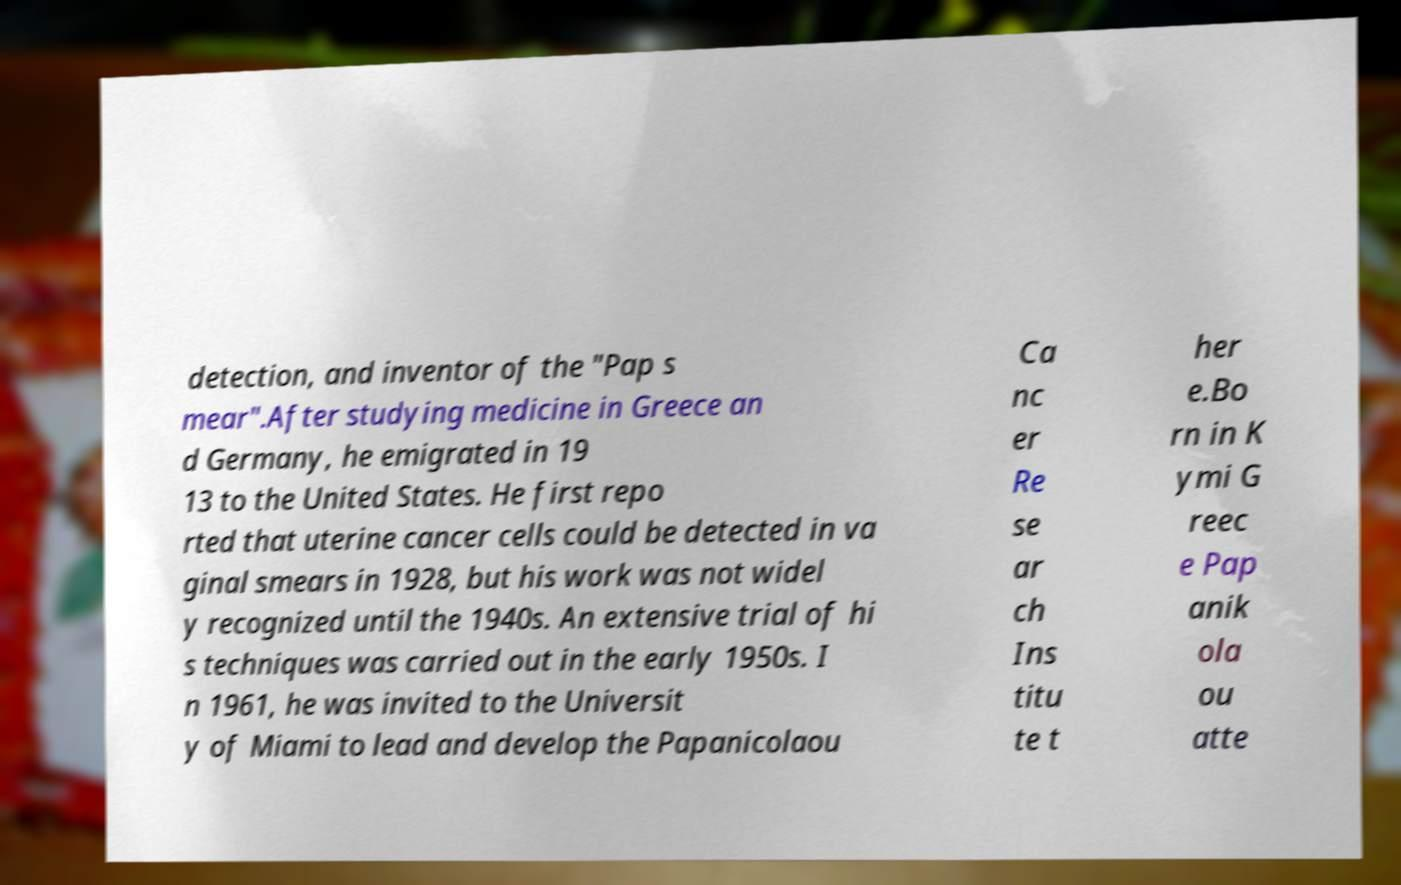Please read and relay the text visible in this image. What does it say? detection, and inventor of the "Pap s mear".After studying medicine in Greece an d Germany, he emigrated in 19 13 to the United States. He first repo rted that uterine cancer cells could be detected in va ginal smears in 1928, but his work was not widel y recognized until the 1940s. An extensive trial of hi s techniques was carried out in the early 1950s. I n 1961, he was invited to the Universit y of Miami to lead and develop the Papanicolaou Ca nc er Re se ar ch Ins titu te t her e.Bo rn in K ymi G reec e Pap anik ola ou atte 